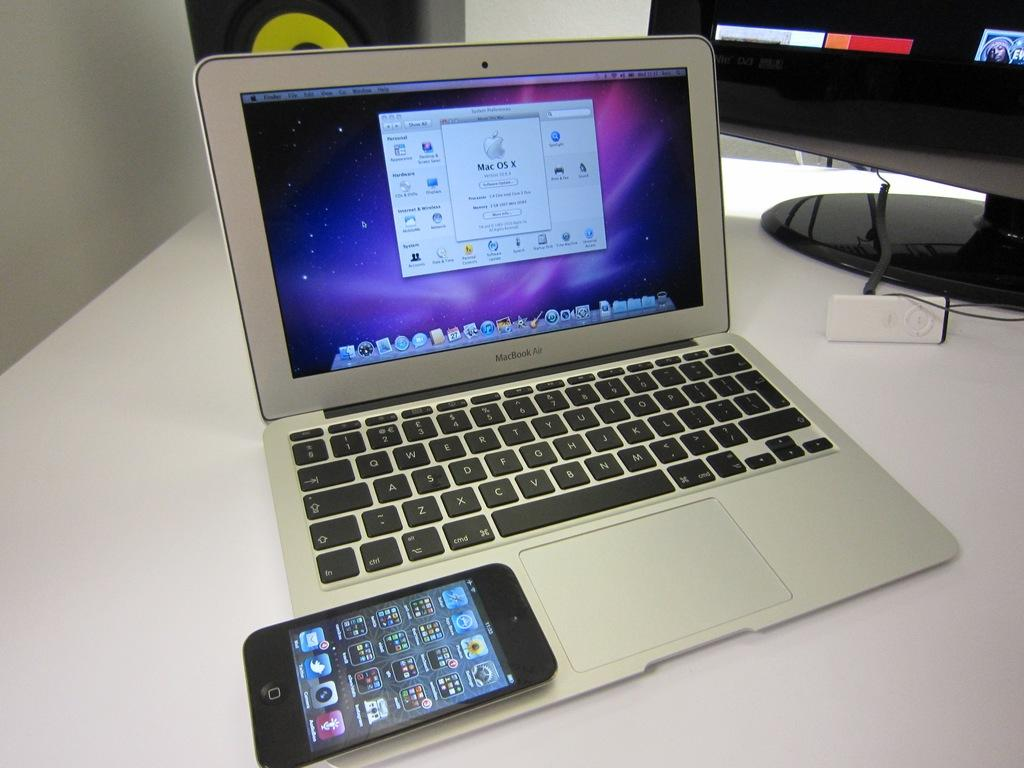<image>
Provide a brief description of the given image. silver macbook air laptop with a black phone laying on it and a monitor to the side 